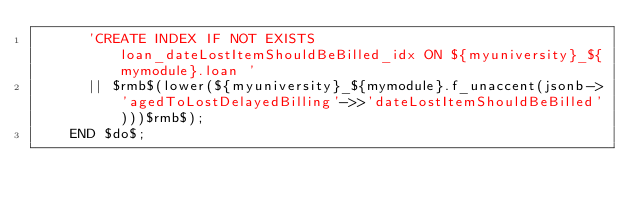Convert code to text. <code><loc_0><loc_0><loc_500><loc_500><_SQL_>      'CREATE INDEX IF NOT EXISTS loan_dateLostItemShouldBeBilled_idx ON ${myuniversity}_${mymodule}.loan '
      || $rmb$(lower(${myuniversity}_${mymodule}.f_unaccent(jsonb->'agedToLostDelayedBilling'->>'dateLostItemShouldBeBilled')))$rmb$);
    END $do$;
</code> 